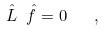<formula> <loc_0><loc_0><loc_500><loc_500>\hat { L } \ \hat { f } = 0 \quad ,</formula> 